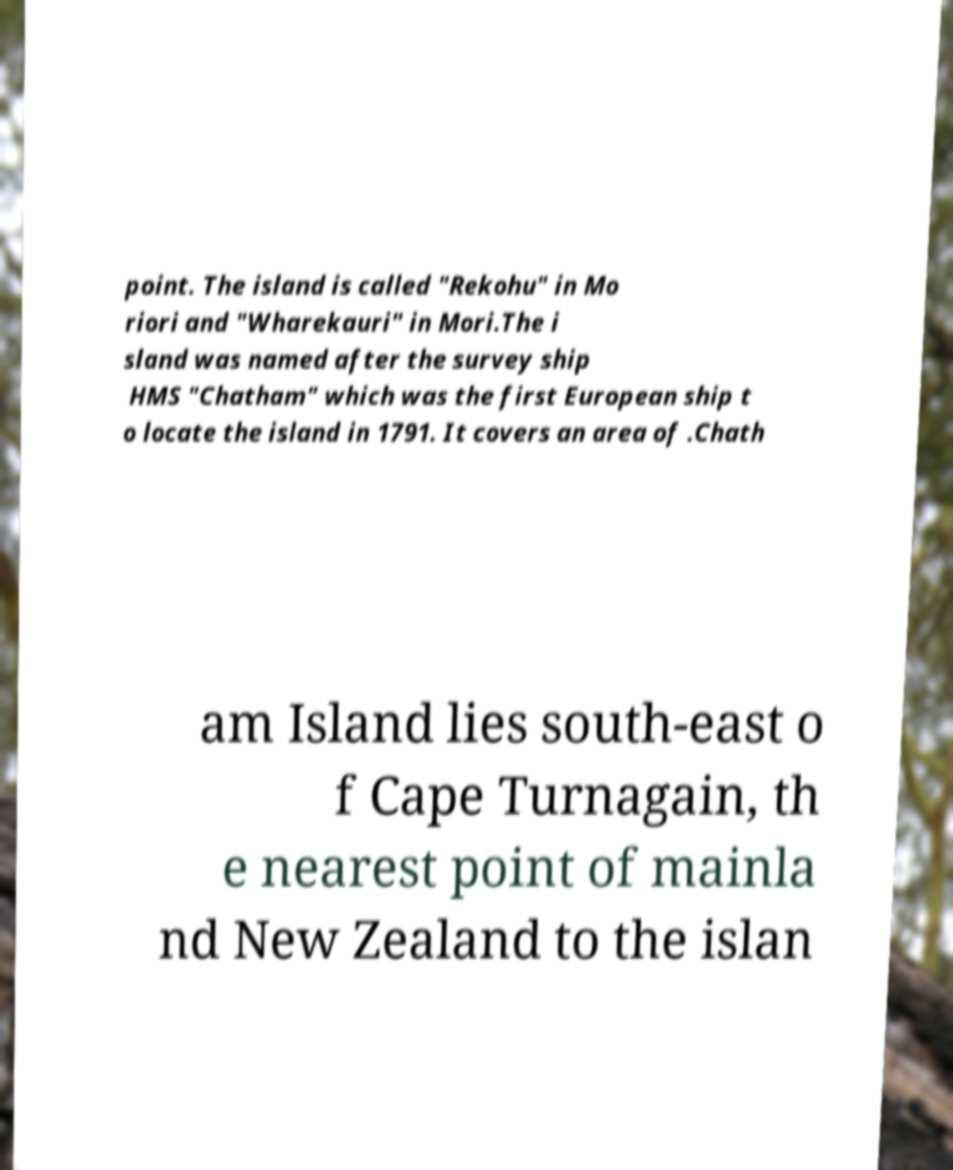Can you read and provide the text displayed in the image?This photo seems to have some interesting text. Can you extract and type it out for me? point. The island is called "Rekohu" in Mo riori and "Wharekauri" in Mori.The i sland was named after the survey ship HMS "Chatham" which was the first European ship t o locate the island in 1791. It covers an area of .Chath am Island lies south-east o f Cape Turnagain, th e nearest point of mainla nd New Zealand to the islan 